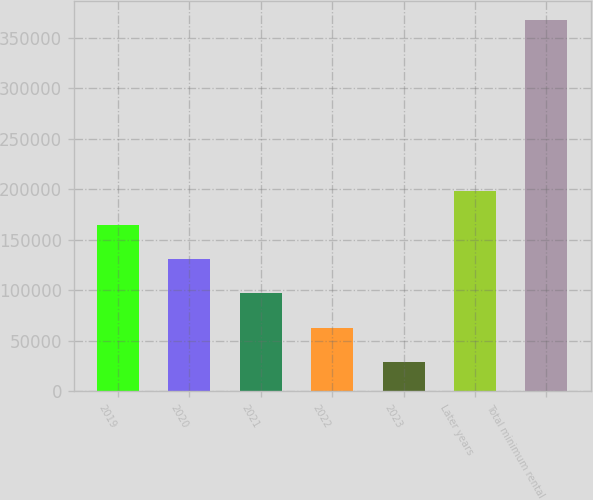<chart> <loc_0><loc_0><loc_500><loc_500><bar_chart><fcel>2019<fcel>2020<fcel>2021<fcel>2022<fcel>2023<fcel>Later years<fcel>Total minimum rental<nl><fcel>164442<fcel>130541<fcel>96640.6<fcel>62739.8<fcel>28839<fcel>198343<fcel>367847<nl></chart> 